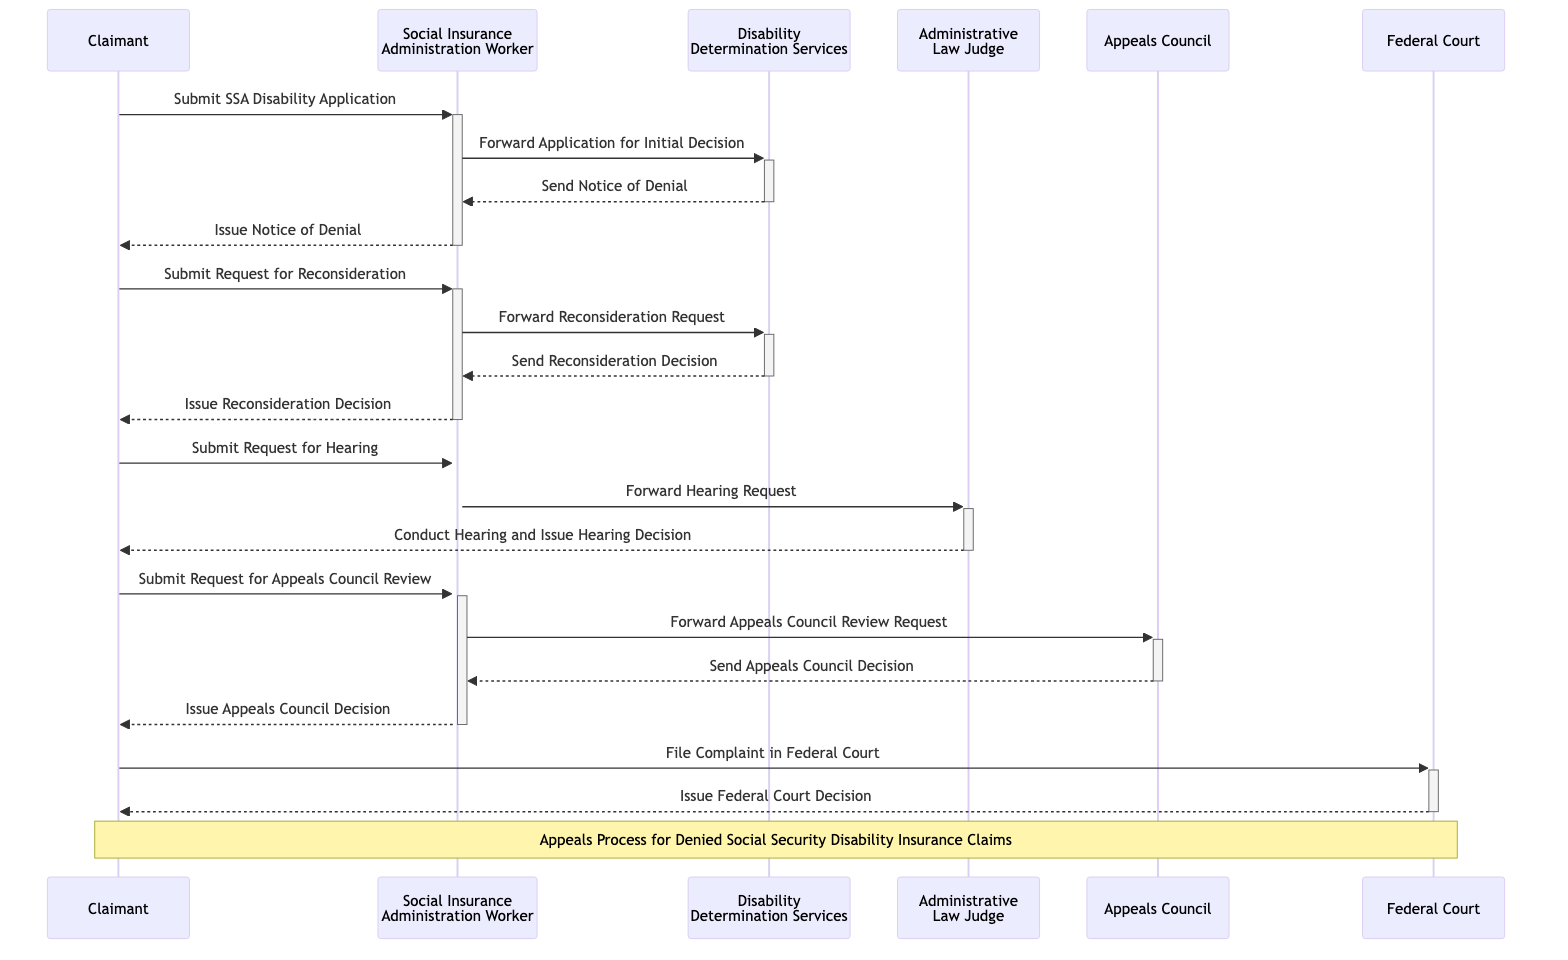What is the first action taken by the Claimant? The Claimant's first action is to submit the SSA Disability Application. This is the initial step in the process depicted in the diagram.
Answer: Submit SSA Disability Application How many decisions are made from the Disability Determination Services? The Disability Determination Services (DDS) makes two decisions: one is a Notice of Denial and the other is a Reconsideration Decision. This can be counted by tracing the outgoing messages from DDS in the diagram.
Answer: 2 What does the Social Insurance Administration Worker issue after receiving the Reconsideration Decision? After receiving the Reconsideration Decision from DDS, the Social Insurance Administration Worker issues the Reconsideration Decision to the Claimant. This is a direct consequence of the flow outlined in the diagram.
Answer: Issue Reconsideration Decision What is the final step before the Federal Court Decision? The final step before the Federal Court Decision is the Claimant filing a Complaint in Federal Court. This action flows directly to the issuance of the Federal Court Decision according to the diagram.
Answer: File Complaint in Federal Court Who conducts the hearing? The Administrative Law Judge (ALJ) conducts the hearing as indicated in the diagram, where they are responsible for conducting the hearing and issuing a decision.
Answer: Administrative Law Judge What communication occurs between the Social Insurance Administration Worker and the Appeals Council? The communication involves the Social Insurance Administration Worker forwarding the Appeals Council Review Request to the Appeals Council. This message is an essential part of the appeals process as depicted in the diagram.
Answer: Forward Appeals Council Review Request How many entities are involved in the appeals process? In the sequence diagram, there are six different entities involved in the appeals process: the Claimant, the Social Insurance Administration Worker, Disability Determination Services (DDS), Administrative Law Judge (ALJ), Appeals Council, and Federal Court.
Answer: 6 What is sent to the Claimant after the Appeals Council Decision? The Social Insurance Administration Worker issues the Appeals Council Decision to the Claimant after receiving it from the Appeals Council as shown in the diagram.
Answer: Issue Appeals Council Decision 